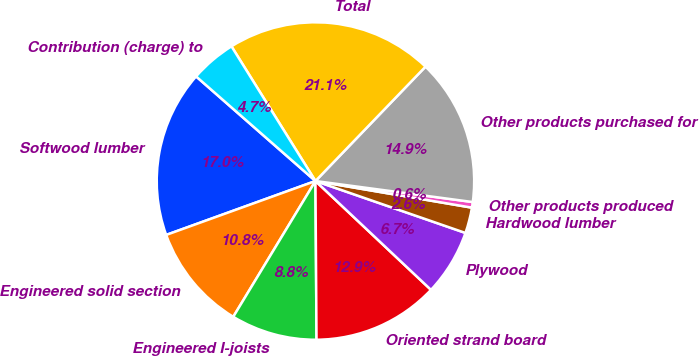<chart> <loc_0><loc_0><loc_500><loc_500><pie_chart><fcel>Softwood lumber<fcel>Engineered solid section<fcel>Engineered I-joists<fcel>Oriented strand board<fcel>Plywood<fcel>Hardwood lumber<fcel>Other products produced<fcel>Other products purchased for<fcel>Total<fcel>Contribution (charge) to<nl><fcel>16.97%<fcel>10.82%<fcel>8.77%<fcel>12.87%<fcel>6.72%<fcel>2.62%<fcel>0.57%<fcel>14.92%<fcel>21.07%<fcel>4.67%<nl></chart> 